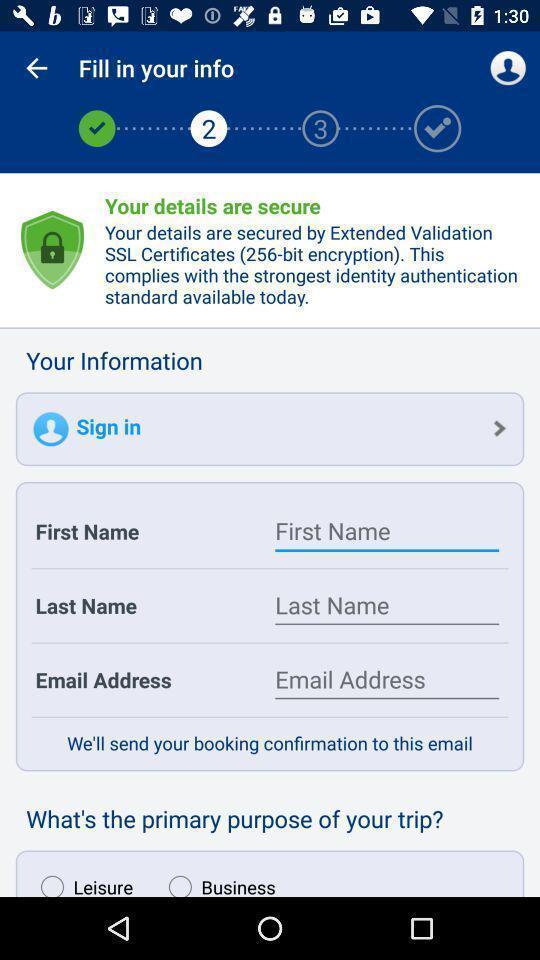Explain what's happening in this screen capture. User information in the fill info. 